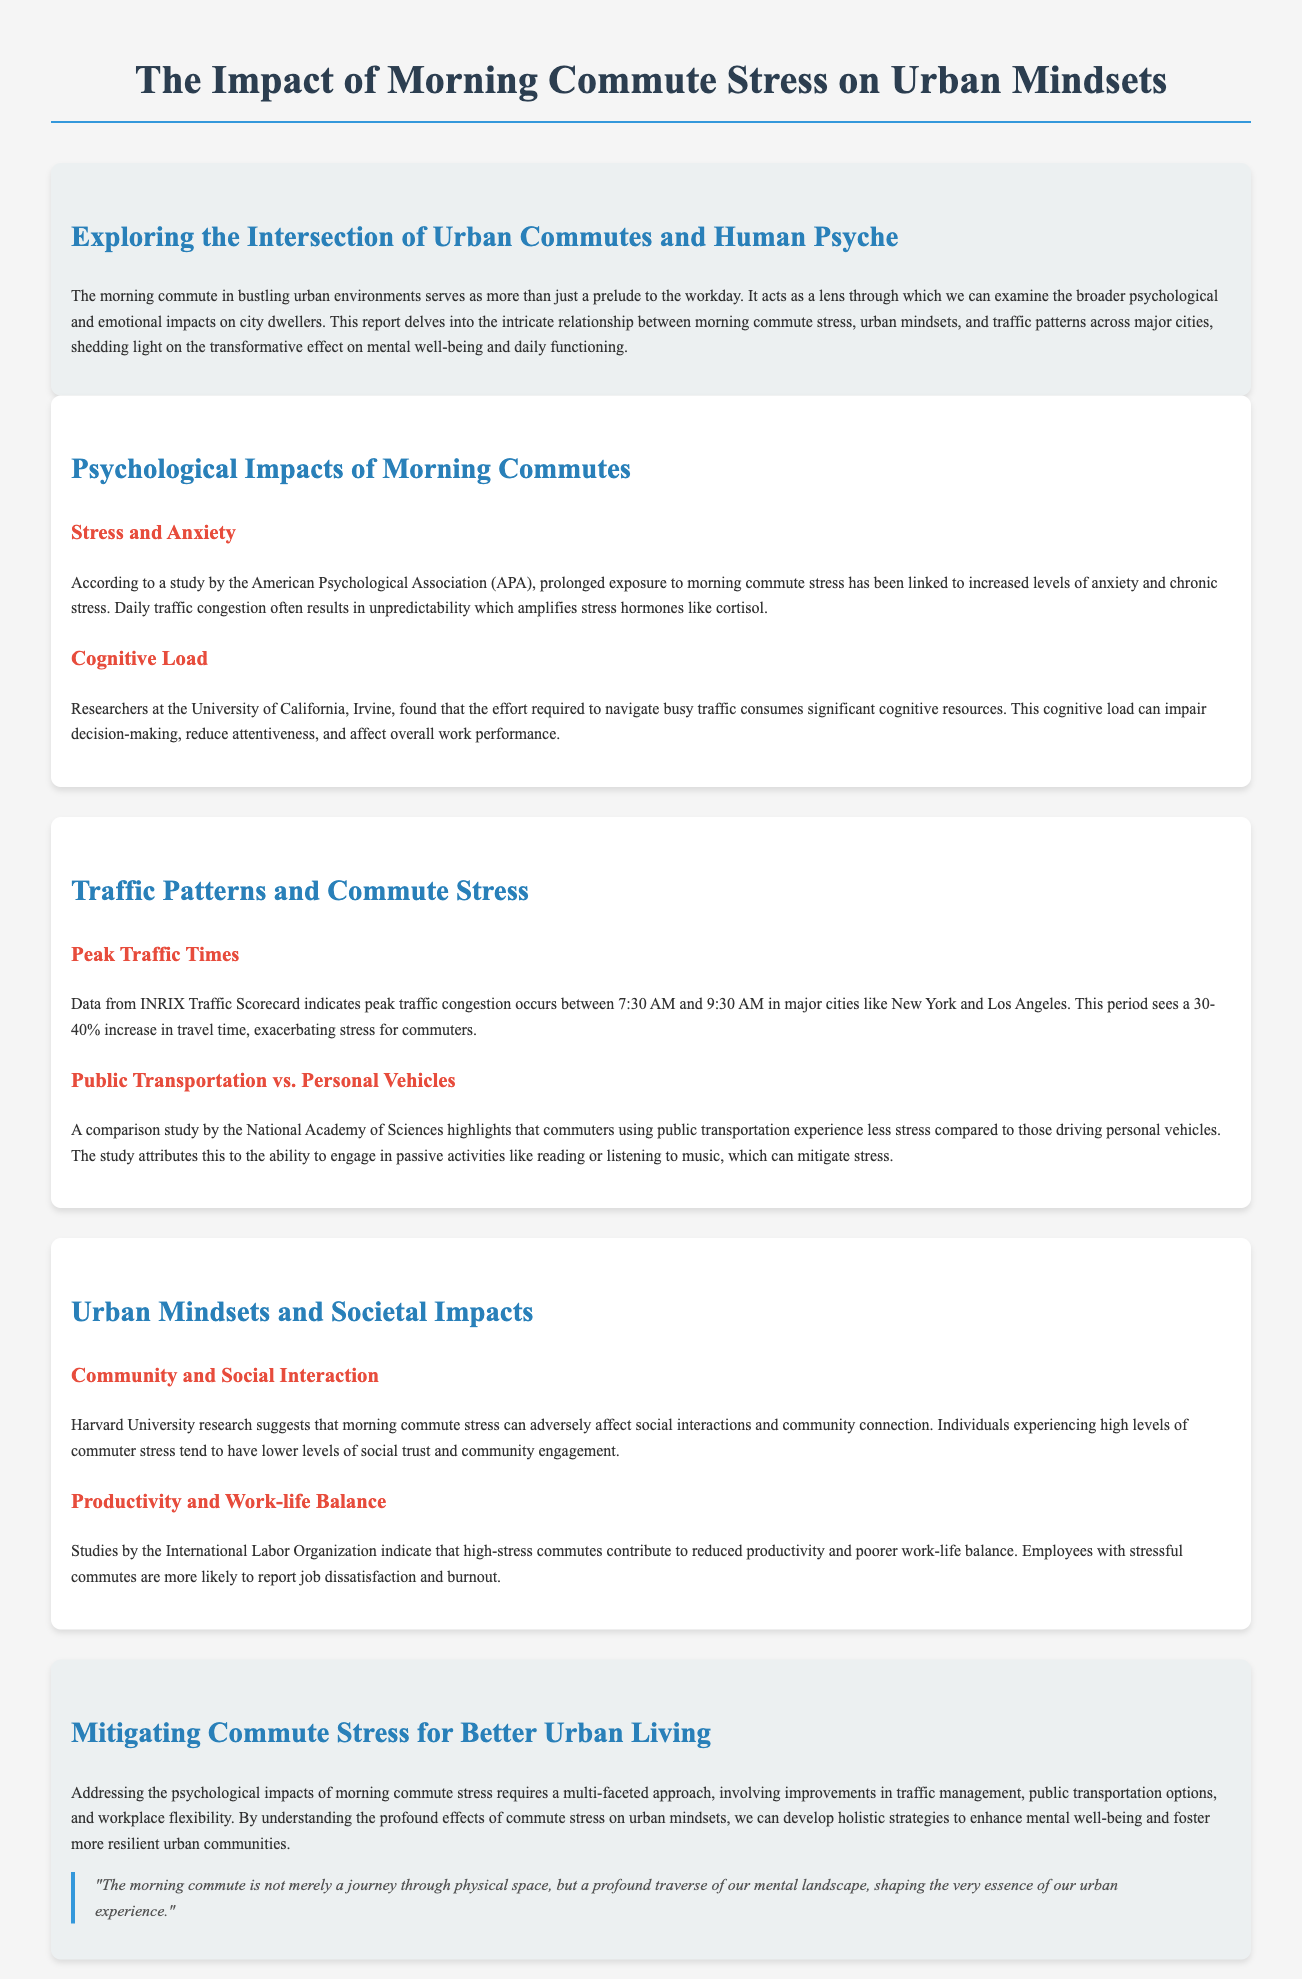What is the title of the report? The title of the report is provided in the header section of the document.
Answer: The Impact of Morning Commute Stress on Urban Mindsets What are peak traffic times in major cities? Peak traffic times are specifically mentioned in the traffic patterns section of the document.
Answer: 7:30 AM to 9:30 AM Which organization conducted the study linking commute stress to anxiety? The study linking commute stress to anxiety is referenced at the beginning of the psychological impacts section.
Answer: American Psychological Association What percentage increase in travel time occurs during peak morning traffic? The traffic patterns section mentions a specific percentage increase in travel time.
Answer: 30-40% What is the main reason public transportation users experience less stress? The reason is described in the sub-section comparing public transportation and personal vehicles.
Answer: Ability to engage in passive activities How does morning commute stress affect social trust? The impact on social trust is discussed in the urban mindsets section of the document.
Answer: Lower levels of social trust According to the International Labor Organization, what do high-stress commutes contribute to? The document specifies the negative outcomes of high-stress commutes.
Answer: Reduced productivity What approach is suggested to mitigate commute stress? The conclusion section outlines a suggested approach to address commute stress.
Answer: Multi-faceted approach 